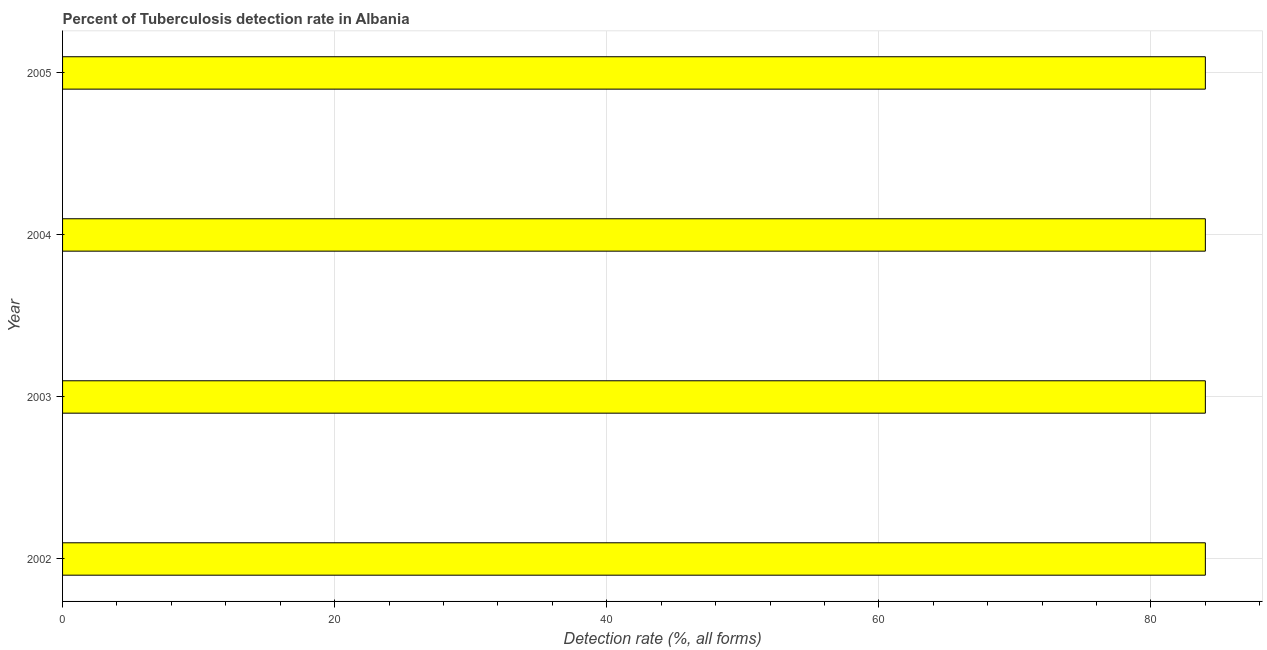What is the title of the graph?
Keep it short and to the point. Percent of Tuberculosis detection rate in Albania. What is the label or title of the X-axis?
Your answer should be compact. Detection rate (%, all forms). What is the detection rate of tuberculosis in 2004?
Keep it short and to the point. 84. Across all years, what is the maximum detection rate of tuberculosis?
Your answer should be compact. 84. Across all years, what is the minimum detection rate of tuberculosis?
Provide a succinct answer. 84. In which year was the detection rate of tuberculosis minimum?
Give a very brief answer. 2002. What is the sum of the detection rate of tuberculosis?
Make the answer very short. 336. What is the median detection rate of tuberculosis?
Make the answer very short. 84. In how many years, is the detection rate of tuberculosis greater than 72 %?
Your response must be concise. 4. Do a majority of the years between 2002 and 2005 (inclusive) have detection rate of tuberculosis greater than 36 %?
Your answer should be compact. Yes. Is the difference between the detection rate of tuberculosis in 2002 and 2004 greater than the difference between any two years?
Provide a succinct answer. Yes. Is the sum of the detection rate of tuberculosis in 2004 and 2005 greater than the maximum detection rate of tuberculosis across all years?
Provide a short and direct response. Yes. What is the difference between the highest and the lowest detection rate of tuberculosis?
Offer a very short reply. 0. In how many years, is the detection rate of tuberculosis greater than the average detection rate of tuberculosis taken over all years?
Give a very brief answer. 0. Are all the bars in the graph horizontal?
Provide a succinct answer. Yes. How many years are there in the graph?
Your response must be concise. 4. What is the difference between two consecutive major ticks on the X-axis?
Your answer should be very brief. 20. What is the Detection rate (%, all forms) in 2005?
Ensure brevity in your answer.  84. What is the difference between the Detection rate (%, all forms) in 2002 and 2004?
Make the answer very short. 0. What is the difference between the Detection rate (%, all forms) in 2003 and 2004?
Ensure brevity in your answer.  0. What is the difference between the Detection rate (%, all forms) in 2003 and 2005?
Offer a terse response. 0. What is the difference between the Detection rate (%, all forms) in 2004 and 2005?
Provide a short and direct response. 0. What is the ratio of the Detection rate (%, all forms) in 2002 to that in 2004?
Your response must be concise. 1. What is the ratio of the Detection rate (%, all forms) in 2003 to that in 2004?
Your answer should be compact. 1. What is the ratio of the Detection rate (%, all forms) in 2003 to that in 2005?
Provide a succinct answer. 1. What is the ratio of the Detection rate (%, all forms) in 2004 to that in 2005?
Give a very brief answer. 1. 